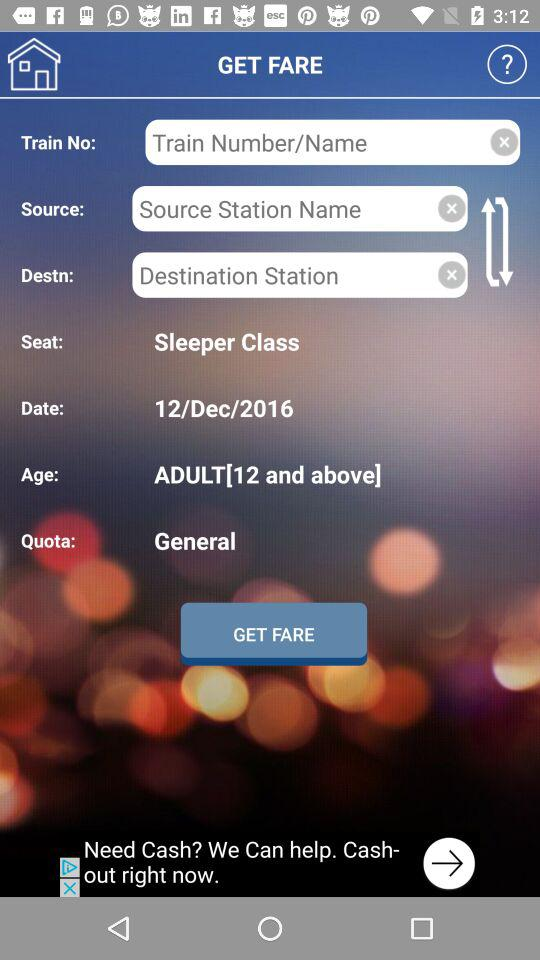What is the selected type of reservation quota? The selected type of reservation quota is general. 